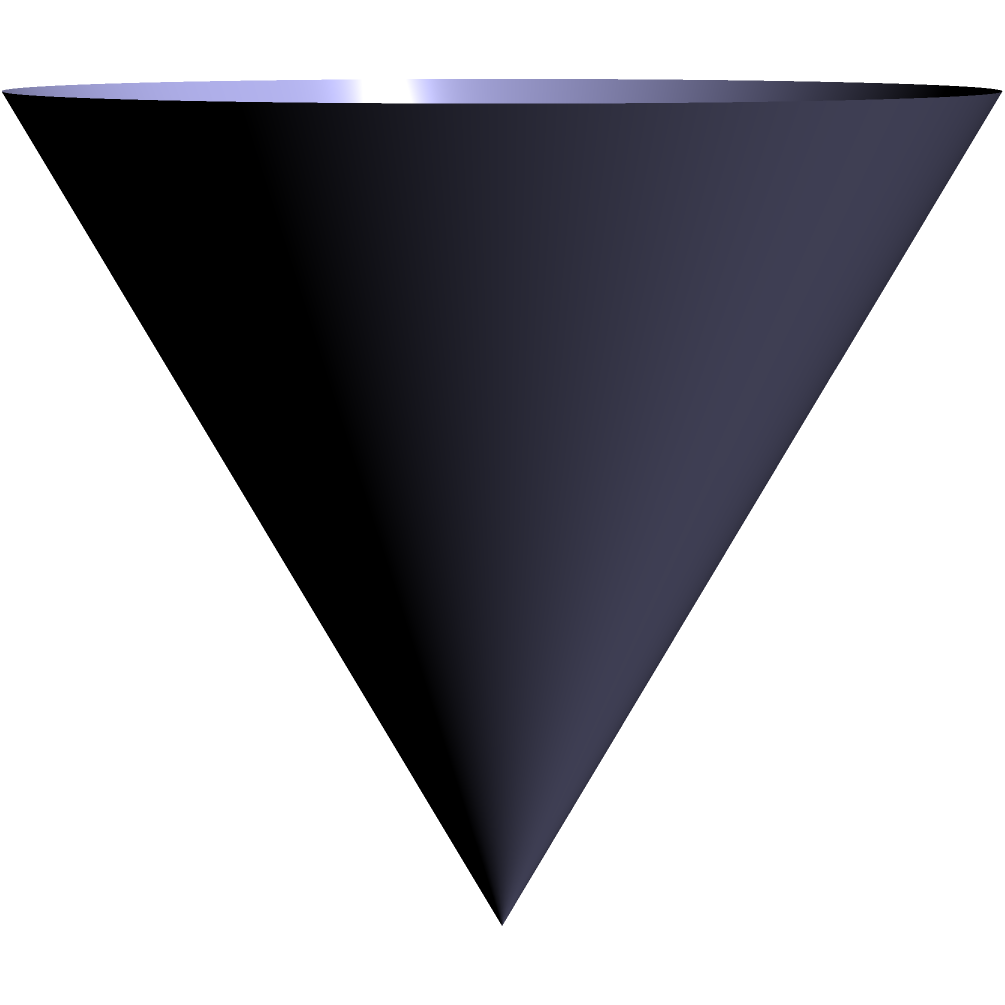A magician wants to create a cone-shaped stack of cards for his grand finale. The base of the cone has a radius of 6 inches, and the height of the cone is 8 inches. Calculate the volume of this cone-shaped stack of cards using the integration method. To find the volume of a cone using integration, we'll follow these steps:

1) The volume of a cone can be calculated by integrating the area of circular cross-sections from the base to the apex.

2) The formula for the volume of a cone using integration is:

   $$V = \int_0^h \pi r(x)^2 dx$$

   where $h$ is the height of the cone and $r(x)$ is the radius at height $x$.

3) In a cone, the radius at any height $x$ is proportional to the distance from the apex:

   $$r(x) = \frac{R}{h}(h-x)$$

   where $R$ is the radius of the base.

4) Substituting this into our volume formula:

   $$V = \int_0^h \pi (\frac{R}{h}(h-x))^2 dx$$

5) Given: $R = 6$ inches, $h = 8$ inches. Let's substitute these values:

   $$V = \int_0^8 \pi (\frac{6}{8}(8-x))^2 dx$$

6) Simplify:
   $$V = \pi (\frac{9}{16}) \int_0^8 (8-x)^2 dx$$

7) Expand $(8-x)^2$:
   $$V = \frac{9\pi}{16} \int_0^8 (64-16x+x^2) dx$$

8) Integrate:
   $$V = \frac{9\pi}{16} [64x-8x^2+\frac{1}{3}x^3]_0^8$$

9) Evaluate the integral:
   $$V = \frac{9\pi}{16} [(512-512+\frac{512}{3}) - 0]$$
   $$V = \frac{9\pi}{16} \cdot \frac{512}{3} = 96\pi$$

10) Therefore, the volume of the cone is $96\pi$ cubic inches.
Answer: $96\pi$ cubic inches 